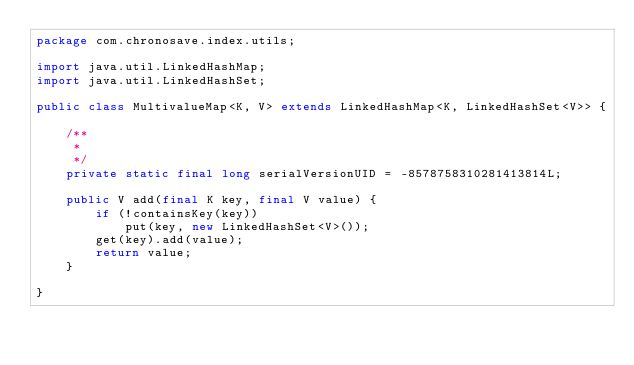Convert code to text. <code><loc_0><loc_0><loc_500><loc_500><_Java_>package com.chronosave.index.utils;

import java.util.LinkedHashMap;
import java.util.LinkedHashSet;

public class MultivalueMap<K, V> extends LinkedHashMap<K, LinkedHashSet<V>> {

	/**
	 *
	 */
	private static final long serialVersionUID = -8578758310281413814L;

	public V add(final K key, final V value) {
		if (!containsKey(key))
			put(key, new LinkedHashSet<V>());
		get(key).add(value);
		return value;
	}

}
</code> 